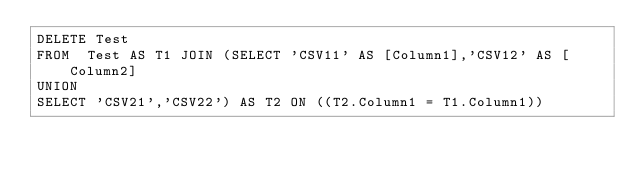Convert code to text. <code><loc_0><loc_0><loc_500><loc_500><_SQL_>DELETE Test
FROM  Test AS T1 JOIN (SELECT 'CSV11' AS [Column1],'CSV12' AS [Column2]
UNION
SELECT 'CSV21','CSV22') AS T2 ON ((T2.Column1 = T1.Column1))
</code> 